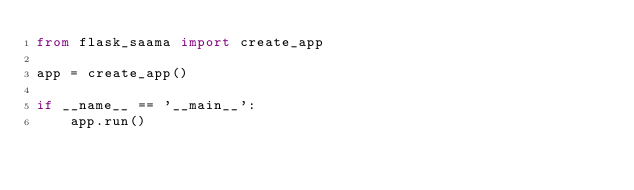<code> <loc_0><loc_0><loc_500><loc_500><_Python_>from flask_saama import create_app

app = create_app()

if __name__ == '__main__':
    app.run()

    </code> 